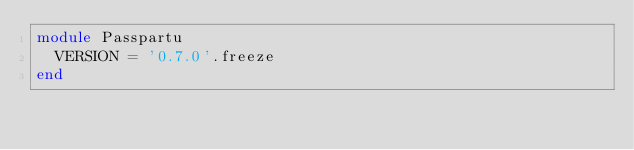Convert code to text. <code><loc_0><loc_0><loc_500><loc_500><_Ruby_>module Passpartu
  VERSION = '0.7.0'.freeze
end
</code> 